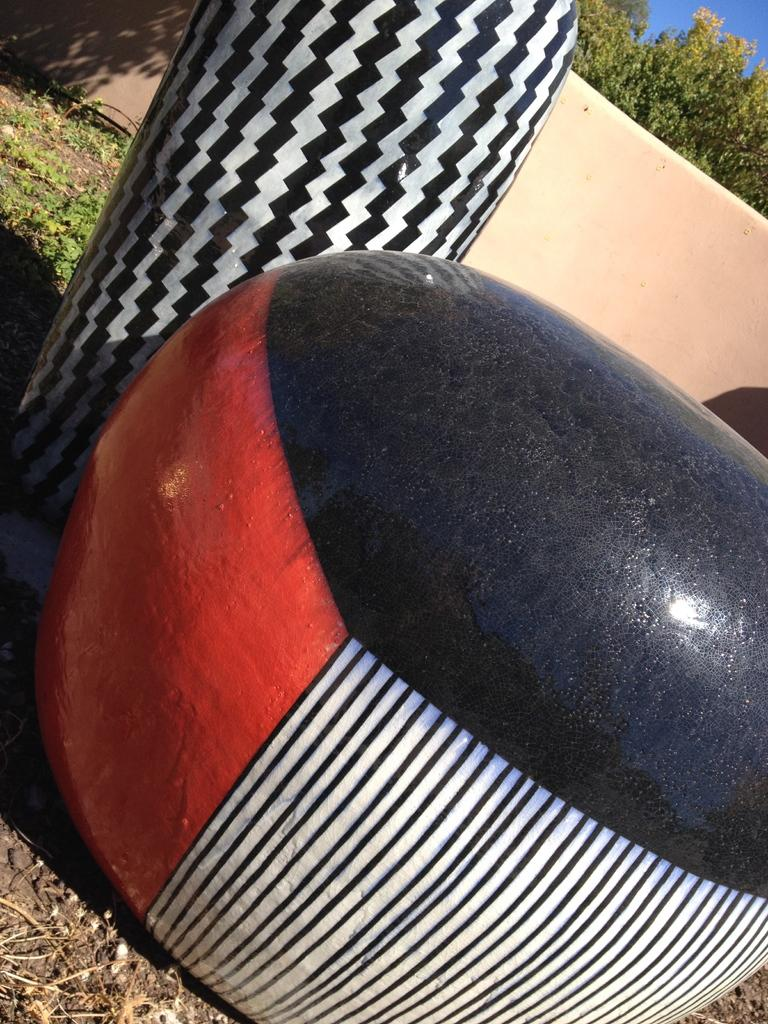What colors are present in the objects in the image? There are objects in black, white, and red colors in the image. What can be seen in the background of the image? There is a wall and trees in the background of the image. How many berries are on the van in the image? There is no van or berries present in the image. 